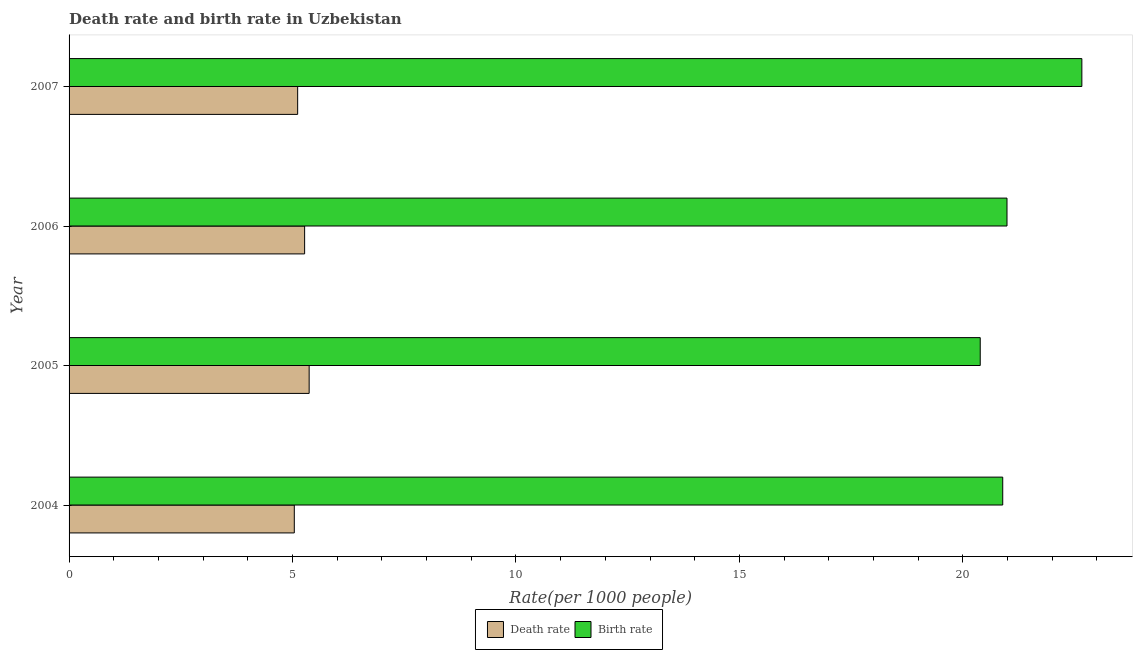How many bars are there on the 2nd tick from the bottom?
Your response must be concise. 2. What is the label of the 2nd group of bars from the top?
Ensure brevity in your answer.  2006. What is the birth rate in 2005?
Offer a very short reply. 20.39. Across all years, what is the maximum birth rate?
Offer a terse response. 22.66. Across all years, what is the minimum death rate?
Offer a very short reply. 5.04. In which year was the death rate maximum?
Give a very brief answer. 2005. In which year was the death rate minimum?
Your answer should be compact. 2004. What is the total death rate in the graph?
Your response must be concise. 20.8. What is the difference between the birth rate in 2004 and that in 2006?
Your answer should be very brief. -0.1. What is the difference between the birth rate in 2006 and the death rate in 2005?
Provide a short and direct response. 15.62. What is the average birth rate per year?
Provide a succinct answer. 21.23. In the year 2006, what is the difference between the birth rate and death rate?
Offer a very short reply. 15.72. In how many years, is the birth rate greater than 22 ?
Keep it short and to the point. 1. What is the ratio of the birth rate in 2004 to that in 2007?
Make the answer very short. 0.92. Is the difference between the death rate in 2005 and 2007 greater than the difference between the birth rate in 2005 and 2007?
Ensure brevity in your answer.  Yes. What is the difference between the highest and the second highest death rate?
Your answer should be compact. 0.1. What is the difference between the highest and the lowest death rate?
Ensure brevity in your answer.  0.33. In how many years, is the birth rate greater than the average birth rate taken over all years?
Ensure brevity in your answer.  1. Is the sum of the death rate in 2004 and 2006 greater than the maximum birth rate across all years?
Your response must be concise. No. What does the 1st bar from the top in 2004 represents?
Provide a short and direct response. Birth rate. What does the 2nd bar from the bottom in 2004 represents?
Ensure brevity in your answer.  Birth rate. Are all the bars in the graph horizontal?
Offer a terse response. Yes. What is the difference between two consecutive major ticks on the X-axis?
Keep it short and to the point. 5. Are the values on the major ticks of X-axis written in scientific E-notation?
Make the answer very short. No. Does the graph contain any zero values?
Keep it short and to the point. No. Does the graph contain grids?
Offer a terse response. No. How many legend labels are there?
Ensure brevity in your answer.  2. What is the title of the graph?
Provide a succinct answer. Death rate and birth rate in Uzbekistan. What is the label or title of the X-axis?
Ensure brevity in your answer.  Rate(per 1000 people). What is the label or title of the Y-axis?
Give a very brief answer. Year. What is the Rate(per 1000 people) of Death rate in 2004?
Offer a terse response. 5.04. What is the Rate(per 1000 people) in Birth rate in 2004?
Make the answer very short. 20.89. What is the Rate(per 1000 people) of Death rate in 2005?
Ensure brevity in your answer.  5.37. What is the Rate(per 1000 people) of Birth rate in 2005?
Provide a short and direct response. 20.39. What is the Rate(per 1000 people) of Death rate in 2006?
Give a very brief answer. 5.27. What is the Rate(per 1000 people) of Birth rate in 2006?
Make the answer very short. 20.99. What is the Rate(per 1000 people) in Death rate in 2007?
Give a very brief answer. 5.12. What is the Rate(per 1000 people) in Birth rate in 2007?
Ensure brevity in your answer.  22.66. Across all years, what is the maximum Rate(per 1000 people) of Death rate?
Your answer should be very brief. 5.37. Across all years, what is the maximum Rate(per 1000 people) of Birth rate?
Your answer should be very brief. 22.66. Across all years, what is the minimum Rate(per 1000 people) of Death rate?
Your answer should be compact. 5.04. Across all years, what is the minimum Rate(per 1000 people) in Birth rate?
Ensure brevity in your answer.  20.39. What is the total Rate(per 1000 people) of Death rate in the graph?
Keep it short and to the point. 20.8. What is the total Rate(per 1000 people) of Birth rate in the graph?
Ensure brevity in your answer.  84.93. What is the difference between the Rate(per 1000 people) of Death rate in 2004 and that in 2005?
Make the answer very short. -0.33. What is the difference between the Rate(per 1000 people) in Birth rate in 2004 and that in 2005?
Provide a succinct answer. 0.5. What is the difference between the Rate(per 1000 people) in Death rate in 2004 and that in 2006?
Your response must be concise. -0.23. What is the difference between the Rate(per 1000 people) of Birth rate in 2004 and that in 2006?
Your answer should be compact. -0.1. What is the difference between the Rate(per 1000 people) in Death rate in 2004 and that in 2007?
Make the answer very short. -0.07. What is the difference between the Rate(per 1000 people) in Birth rate in 2004 and that in 2007?
Give a very brief answer. -1.77. What is the difference between the Rate(per 1000 people) of Death rate in 2005 and that in 2006?
Your answer should be very brief. 0.1. What is the difference between the Rate(per 1000 people) of Birth rate in 2005 and that in 2006?
Make the answer very short. -0.6. What is the difference between the Rate(per 1000 people) of Death rate in 2005 and that in 2007?
Offer a terse response. 0.26. What is the difference between the Rate(per 1000 people) in Birth rate in 2005 and that in 2007?
Make the answer very short. -2.27. What is the difference between the Rate(per 1000 people) in Death rate in 2006 and that in 2007?
Give a very brief answer. 0.16. What is the difference between the Rate(per 1000 people) in Birth rate in 2006 and that in 2007?
Offer a very short reply. -1.67. What is the difference between the Rate(per 1000 people) of Death rate in 2004 and the Rate(per 1000 people) of Birth rate in 2005?
Offer a terse response. -15.35. What is the difference between the Rate(per 1000 people) in Death rate in 2004 and the Rate(per 1000 people) in Birth rate in 2006?
Make the answer very short. -15.95. What is the difference between the Rate(per 1000 people) in Death rate in 2004 and the Rate(per 1000 people) in Birth rate in 2007?
Your answer should be very brief. -17.62. What is the difference between the Rate(per 1000 people) of Death rate in 2005 and the Rate(per 1000 people) of Birth rate in 2006?
Ensure brevity in your answer.  -15.62. What is the difference between the Rate(per 1000 people) of Death rate in 2005 and the Rate(per 1000 people) of Birth rate in 2007?
Your response must be concise. -17.29. What is the difference between the Rate(per 1000 people) of Death rate in 2006 and the Rate(per 1000 people) of Birth rate in 2007?
Provide a short and direct response. -17.39. What is the average Rate(per 1000 people) of Death rate per year?
Make the answer very short. 5.2. What is the average Rate(per 1000 people) of Birth rate per year?
Your response must be concise. 21.23. In the year 2004, what is the difference between the Rate(per 1000 people) of Death rate and Rate(per 1000 people) of Birth rate?
Provide a succinct answer. -15.85. In the year 2005, what is the difference between the Rate(per 1000 people) in Death rate and Rate(per 1000 people) in Birth rate?
Ensure brevity in your answer.  -15.02. In the year 2006, what is the difference between the Rate(per 1000 people) in Death rate and Rate(per 1000 people) in Birth rate?
Provide a succinct answer. -15.72. In the year 2007, what is the difference between the Rate(per 1000 people) in Death rate and Rate(per 1000 people) in Birth rate?
Offer a terse response. -17.55. What is the ratio of the Rate(per 1000 people) of Death rate in 2004 to that in 2005?
Offer a very short reply. 0.94. What is the ratio of the Rate(per 1000 people) of Birth rate in 2004 to that in 2005?
Make the answer very short. 1.02. What is the ratio of the Rate(per 1000 people) in Death rate in 2004 to that in 2006?
Give a very brief answer. 0.96. What is the ratio of the Rate(per 1000 people) of Birth rate in 2004 to that in 2007?
Ensure brevity in your answer.  0.92. What is the ratio of the Rate(per 1000 people) of Death rate in 2005 to that in 2006?
Your response must be concise. 1.02. What is the ratio of the Rate(per 1000 people) in Birth rate in 2005 to that in 2006?
Make the answer very short. 0.97. What is the ratio of the Rate(per 1000 people) in Death rate in 2005 to that in 2007?
Provide a succinct answer. 1.05. What is the ratio of the Rate(per 1000 people) in Birth rate in 2005 to that in 2007?
Ensure brevity in your answer.  0.9. What is the ratio of the Rate(per 1000 people) of Death rate in 2006 to that in 2007?
Your response must be concise. 1.03. What is the ratio of the Rate(per 1000 people) of Birth rate in 2006 to that in 2007?
Give a very brief answer. 0.93. What is the difference between the highest and the second highest Rate(per 1000 people) of Death rate?
Keep it short and to the point. 0.1. What is the difference between the highest and the second highest Rate(per 1000 people) in Birth rate?
Ensure brevity in your answer.  1.67. What is the difference between the highest and the lowest Rate(per 1000 people) in Death rate?
Ensure brevity in your answer.  0.33. What is the difference between the highest and the lowest Rate(per 1000 people) of Birth rate?
Give a very brief answer. 2.27. 